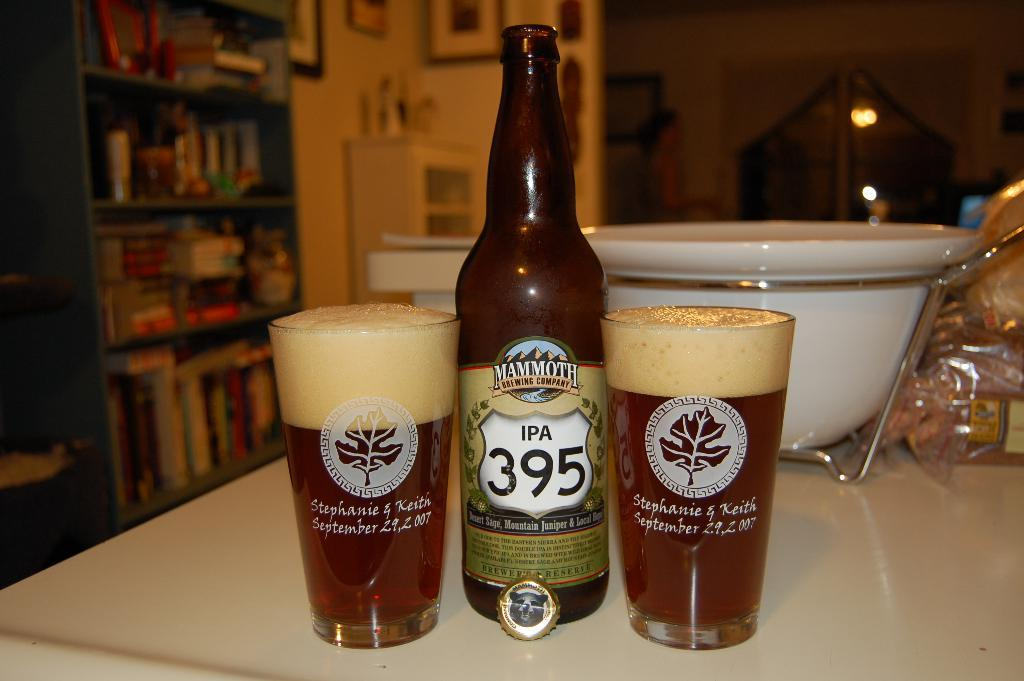Provide a one-sentence caption for the provided image. Two full glasses of ale sit next to a 395 IPA bottle. 